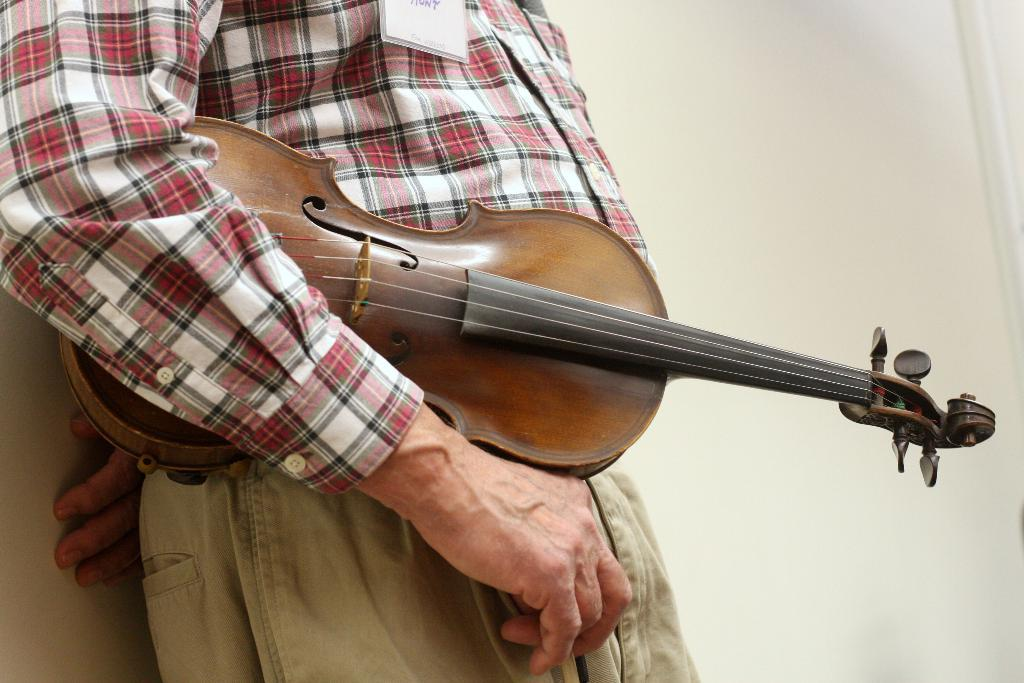What is the person in the image holding? The person is holding a musical instrument. What can be seen in the background of the image? There is a wall in the background of the image. What type of cheese is being used to create a quilt in the image? There is no cheese or quilt present in the image; it features a person holding a musical instrument and a wall in the background. 